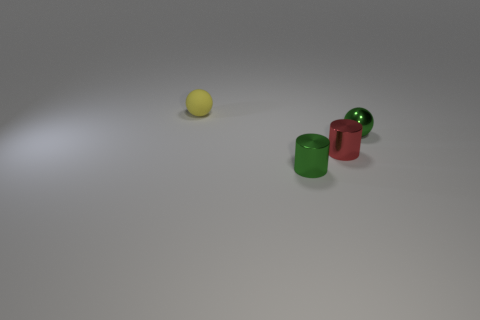Add 4 green cylinders. How many objects exist? 8 Subtract all red cylinders. How many cylinders are left? 1 Subtract 1 spheres. How many spheres are left? 1 Subtract all red cylinders. How many green spheres are left? 1 Subtract 1 green balls. How many objects are left? 3 Subtract all green cylinders. Subtract all cyan spheres. How many cylinders are left? 1 Subtract all green objects. Subtract all yellow rubber balls. How many objects are left? 1 Add 2 shiny things. How many shiny things are left? 5 Add 2 tiny yellow matte spheres. How many tiny yellow matte spheres exist? 3 